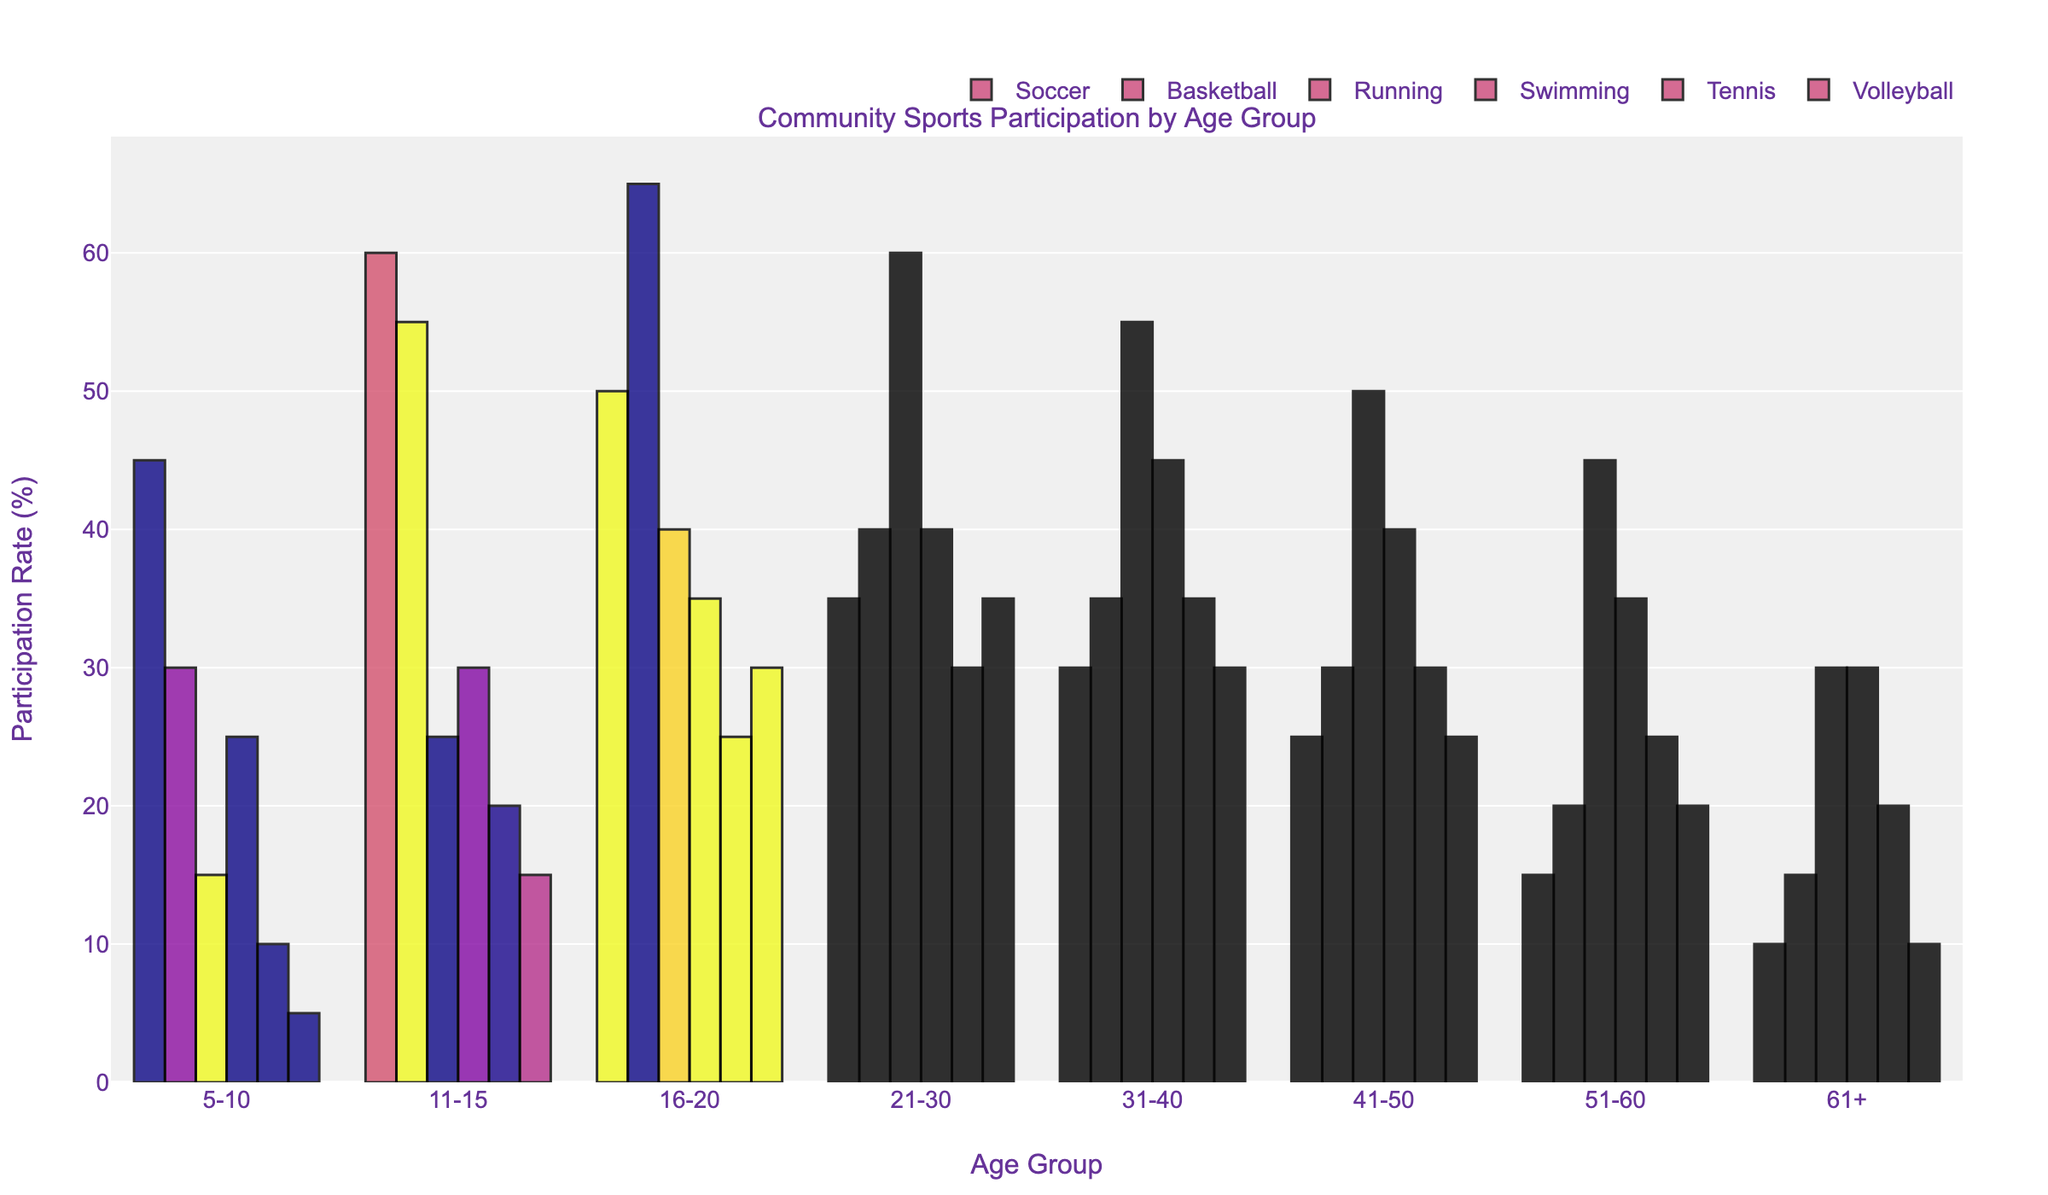What is the participation rate in Soccer for the 11-15 age group? Look at the bar corresponding to Soccer and the 11-15 age group. The height represents the participation rate.
Answer: 60 Which age group has the highest participation rate in Running? Compare the heights of the bars corresponding to Running across all age groups. The tallest bar represents the highest participation rate.
Answer: 21-30 How does the participation rate in Swimming change from the 5-10 age group to the 31-40 age group? Observe the heights of the Swimming bars for the 5-10 and the 31-40 age groups and calculate the difference.
Answer: Increases by 20% Which sport has the lowest overall participation rate in the 61+ age group? Compare the heights of all sports bars in the 61+ age group. The shortest bar represents the lowest participation rate.
Answer: Volleyball Between what age groups does the participation in Tennis show the most significant increase? Compare the differences in the heights of the Tennis bars across consecutive age groups to find the largest increase.
Answer: 11-15 to 16-20 What is the combined participation rate in Volleyball and Basketball for the 21-30 age group? Sum the heights of the Volleyball and Basketball bars for the 21-30 age group.
Answer: 75 Is the participation rate in Soccer higher than in Swimming for the 41-50 age group? Compare the heights of the Soccer and Swimming bars for the 41-50 age group.
Answer: No Which age group has the most balanced participation rate across all sports? Look for the age group where the heights of the bars are most similar.
Answer: 31-40 